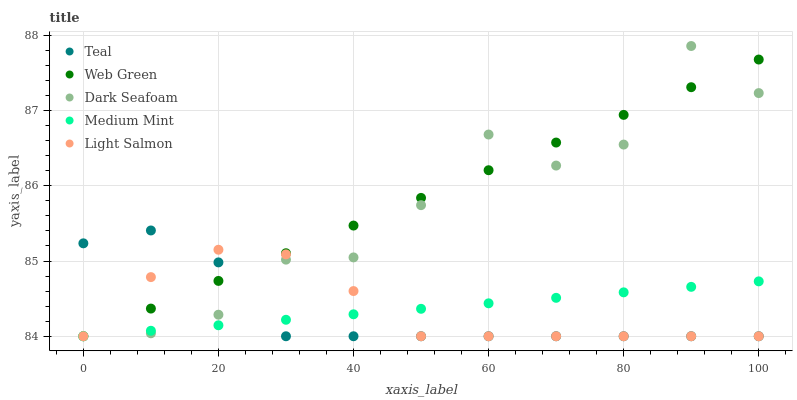Does Teal have the minimum area under the curve?
Answer yes or no. Yes. Does Web Green have the maximum area under the curve?
Answer yes or no. Yes. Does Dark Seafoam have the minimum area under the curve?
Answer yes or no. No. Does Dark Seafoam have the maximum area under the curve?
Answer yes or no. No. Is Medium Mint the smoothest?
Answer yes or no. Yes. Is Dark Seafoam the roughest?
Answer yes or no. Yes. Is Web Green the smoothest?
Answer yes or no. No. Is Web Green the roughest?
Answer yes or no. No. Does Medium Mint have the lowest value?
Answer yes or no. Yes. Does Dark Seafoam have the highest value?
Answer yes or no. Yes. Does Web Green have the highest value?
Answer yes or no. No. Does Dark Seafoam intersect Teal?
Answer yes or no. Yes. Is Dark Seafoam less than Teal?
Answer yes or no. No. Is Dark Seafoam greater than Teal?
Answer yes or no. No. 